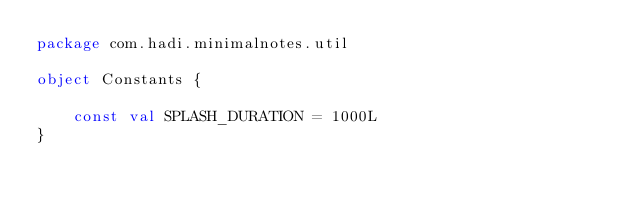<code> <loc_0><loc_0><loc_500><loc_500><_Kotlin_>package com.hadi.minimalnotes.util

object Constants {

    const val SPLASH_DURATION = 1000L
}</code> 